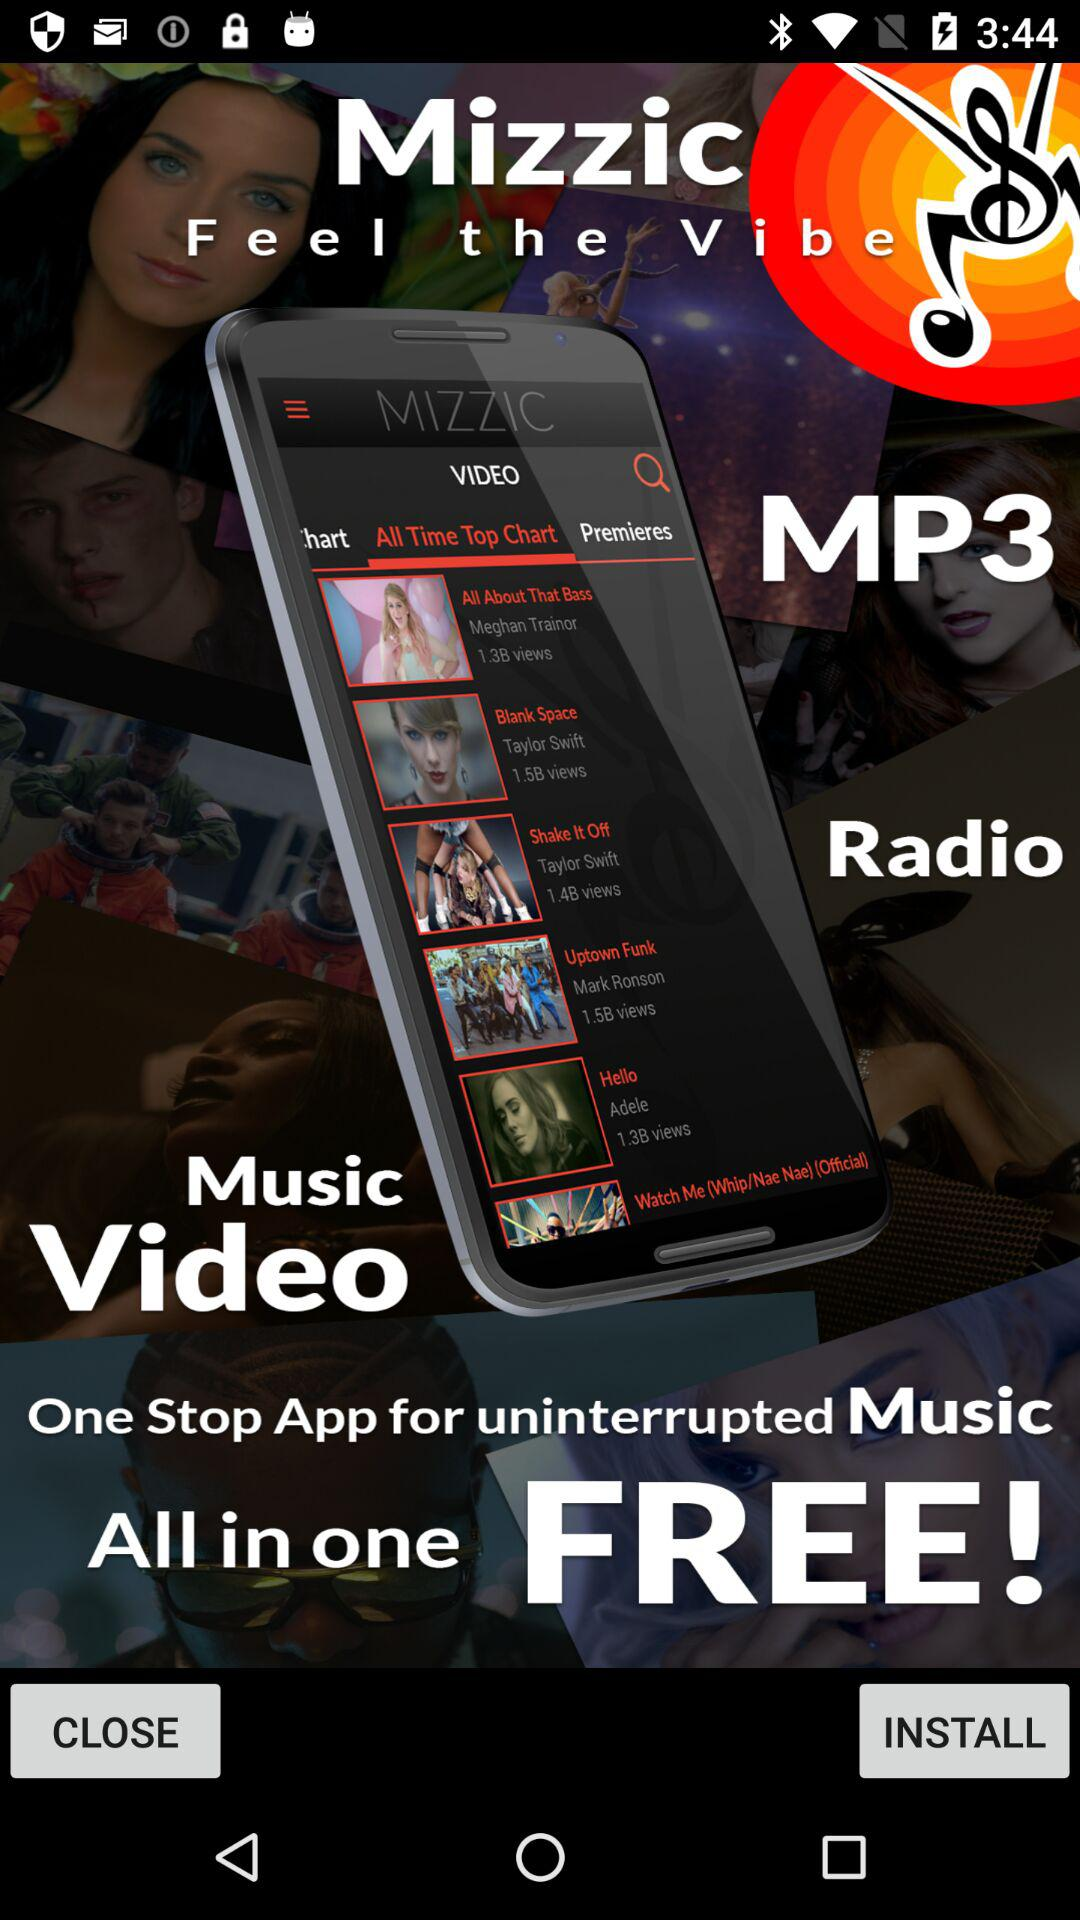What is the application name? The application name is "Mizzic". 